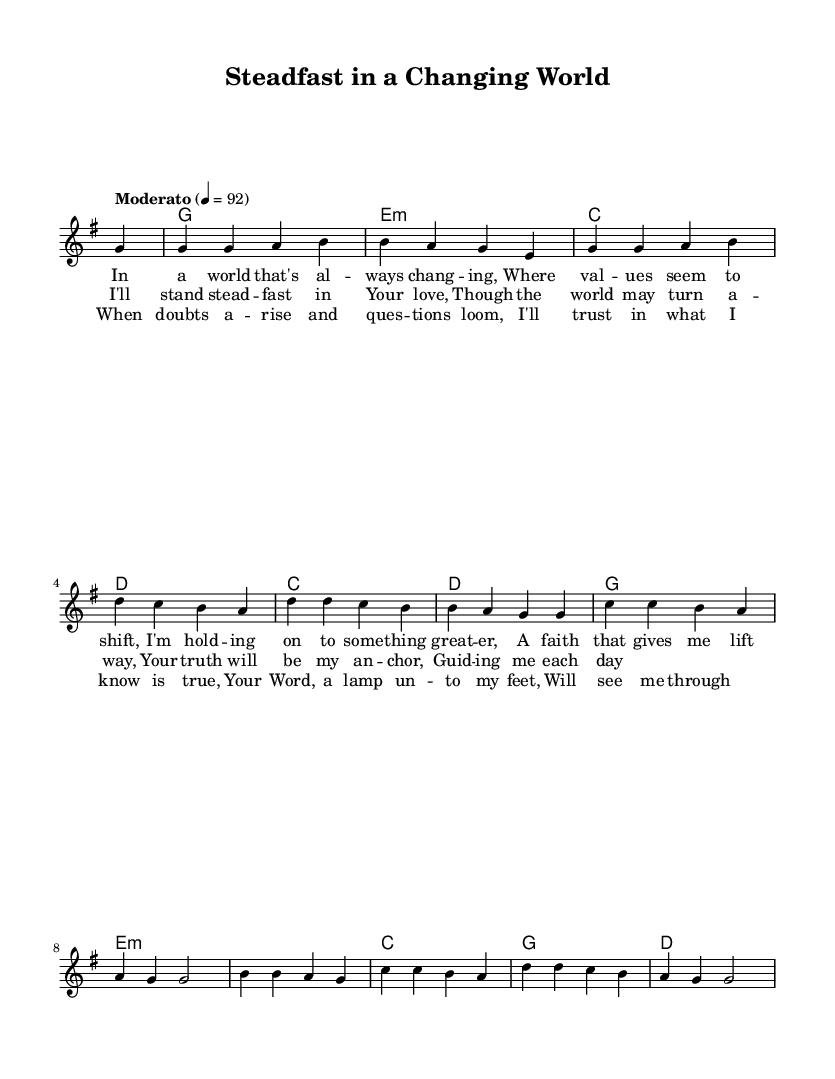What is the key signature of this music? The key signature is indicated by the "g" mentioned in the global settings, which suggests that there is one sharp, marking it as G major.
Answer: G major What is the time signature of this piece? The time signature is explicitly stated in the global settings as "4/4," which means there are four beats in each measure.
Answer: 4/4 What is the tempo marking for this composition? The tempo is provided as "Moderato" with a metronome marking of "4 = 92," indicating a moderate pace, specifically set to 92 beats per minute.
Answer: Moderato, 92 What is the last chord played before the bridge begins? The last chord in the harmonies prior to the bridge is "d", denoting a D major chord.
Answer: D In which section does the phrase "Your Word, a lamp unto my feet," appear? Analyzing the lyrics, this phrase is found in the bridge section, indicating a place of trust in faith amidst doubt.
Answer: Bridge What does the chorus convey about the singer's faith? The chorus expresses a strong commitment to staying faithful and anchored in God's love despite external challenges, as shown through the lyrics.
Answer: Commitment 